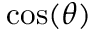Convert formula to latex. <formula><loc_0><loc_0><loc_500><loc_500>\cos ( \theta )</formula> 